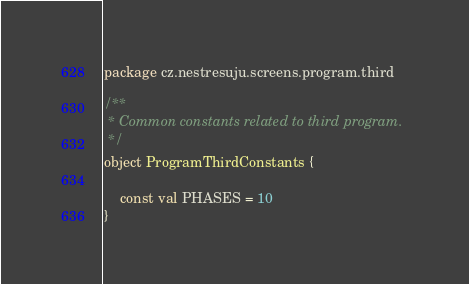<code> <loc_0><loc_0><loc_500><loc_500><_Kotlin_>package cz.nestresuju.screens.program.third

/**
 * Common constants related to third program.
 */
object ProgramThirdConstants {

    const val PHASES = 10
}</code> 